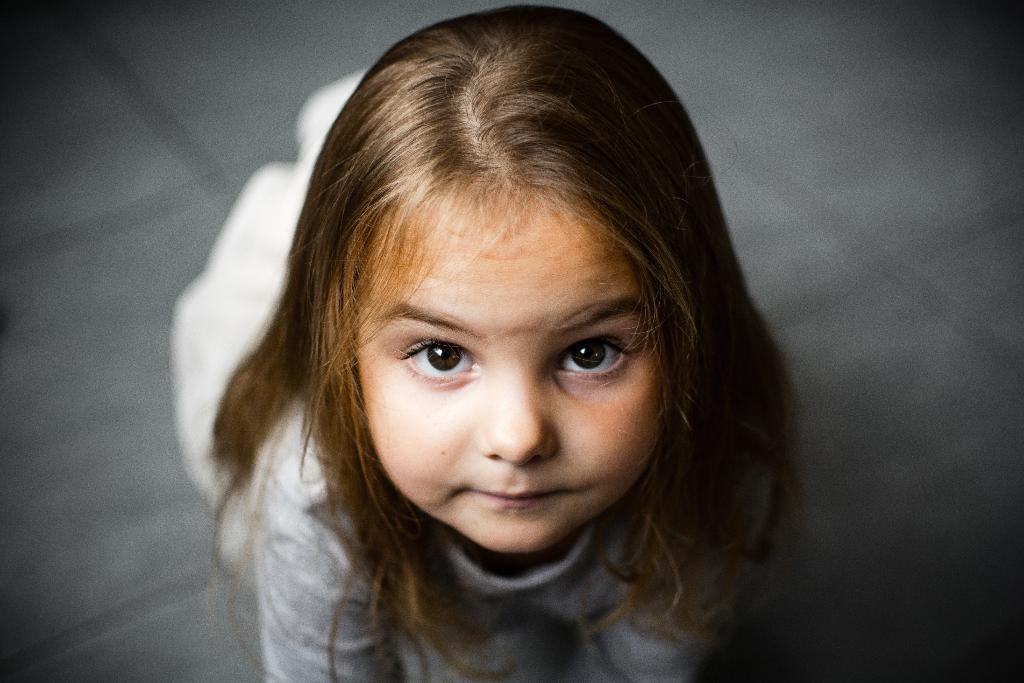Who is the main subject in the image? There is a girl in the image. What is the girl wearing? The girl is wearing a white dress. Can you describe the quality of the image's background? The image is blurry in the background. What direction is the bear facing in the image? There is no bear present in the image. What is the girl using to stir the contents of the pot in the image? There is no pot or stirring tool visible in the image. 